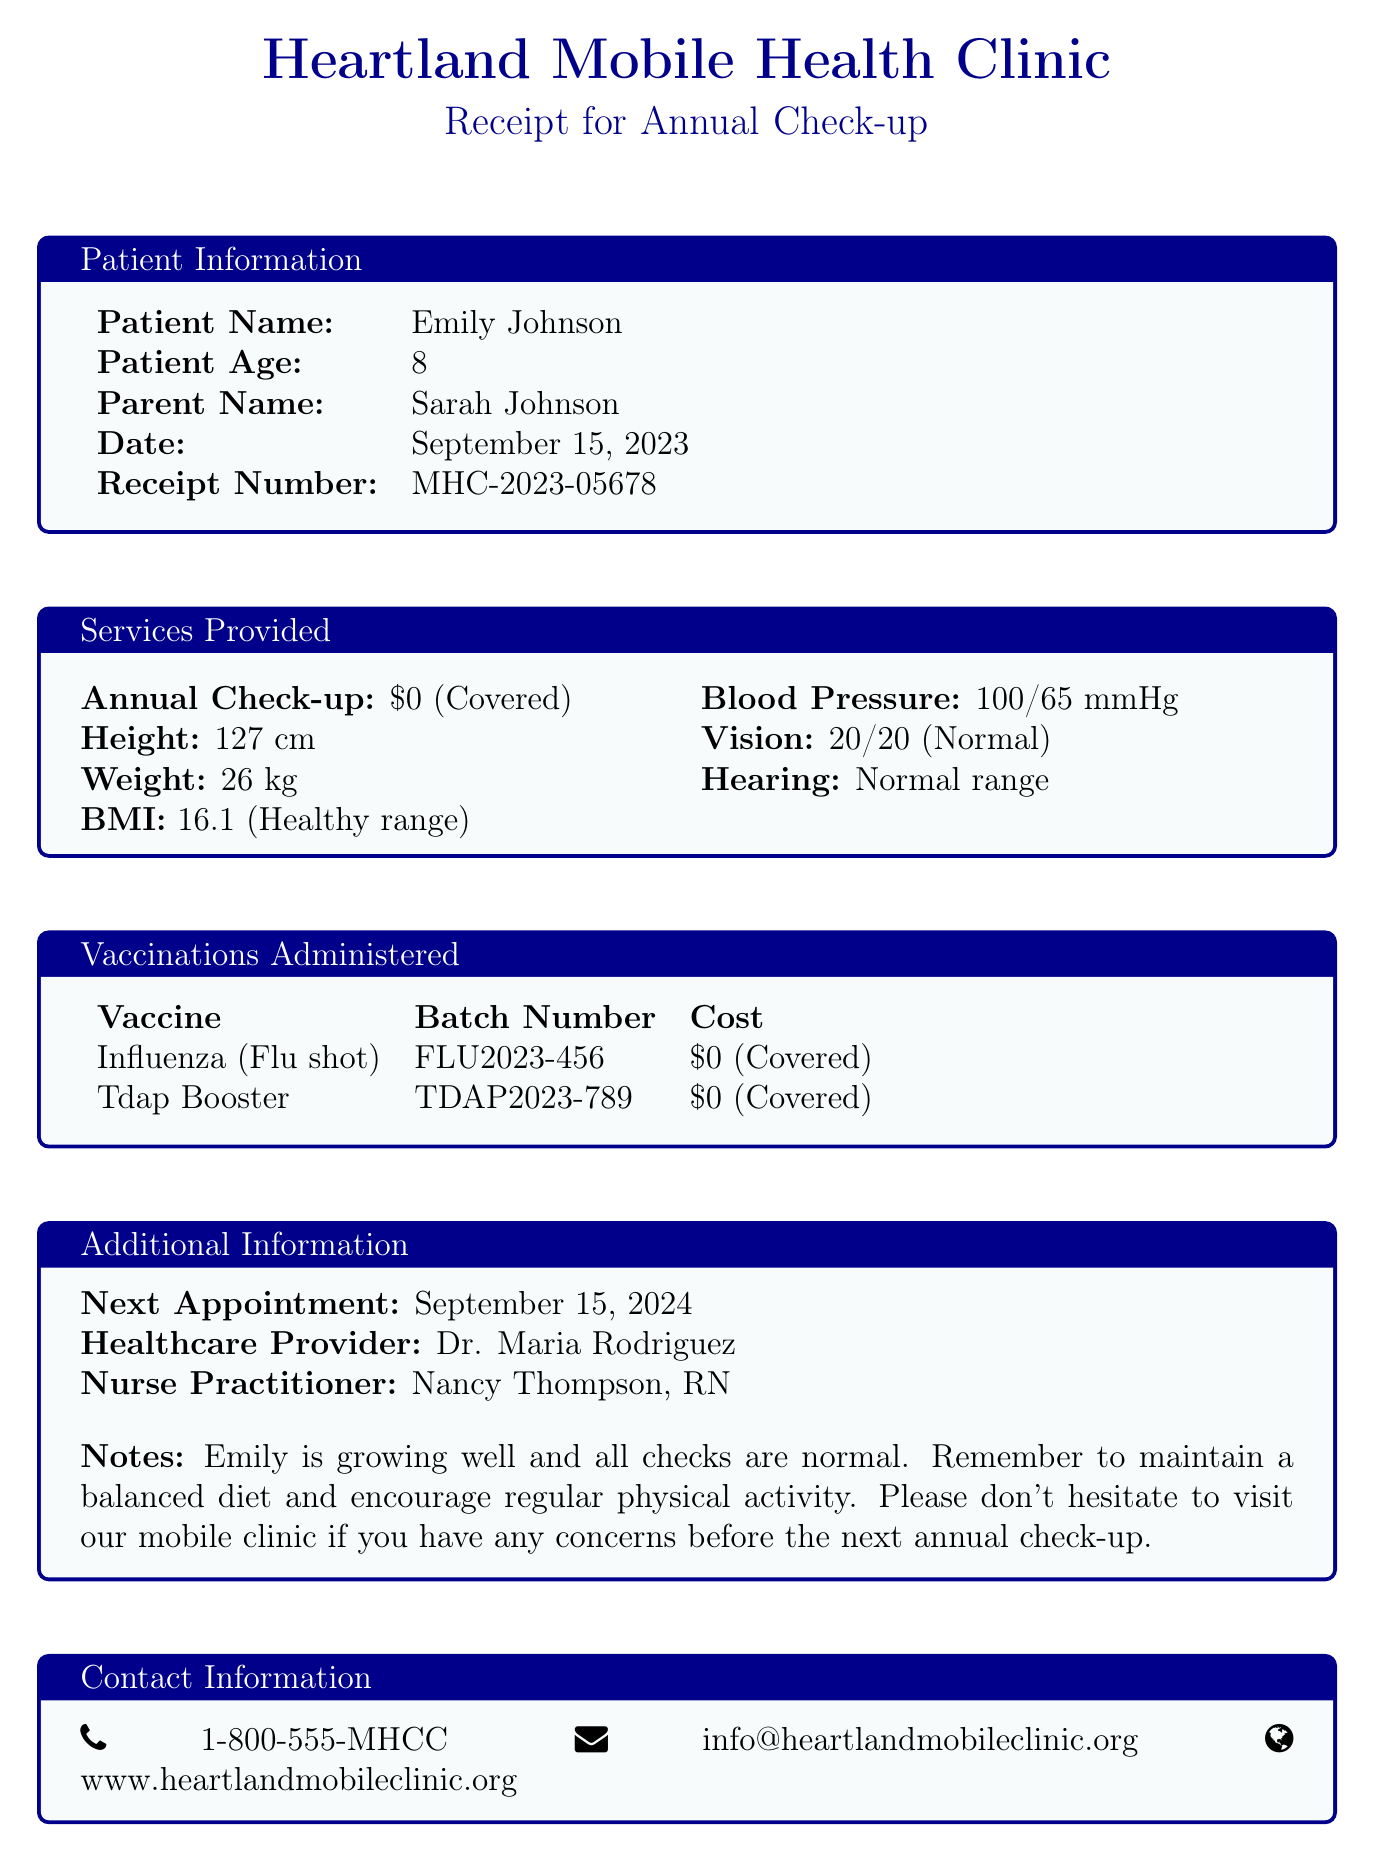what is the name of the clinic? The name of the clinic is mentioned at the top of the receipt.
Answer: Heartland Mobile Health Clinic what is the receipt number? The receipt number is listed under the patient information section of the receipt.
Answer: MHC-2023-05678 when was the clinic visit? The date of the visit is provided in the patient information section.
Answer: September 15, 2023 who is the healthcare provider? The name of the healthcare provider is stated in the additional information section.
Answer: Dr. Maria Rodriguez what vaccinations were administered? The vaccines administered are listed in the vaccinations administered section.
Answer: Influenza (Flu shot), Tdap Booster what was Emily's weight? The weight measurement of the patient is provided in the services provided section.
Answer: 26 kg what is Emily's height? The height measurement is found in the services provided section of the document.
Answer: 127 cm what is the next appointment date? The next appointment date is clearly mentioned in the additional information section.
Answer: September 15, 2024 what is the contact phone number for the clinic? The contact phone number is located in the contact information section.
Answer: 1-800-555-MHCC 